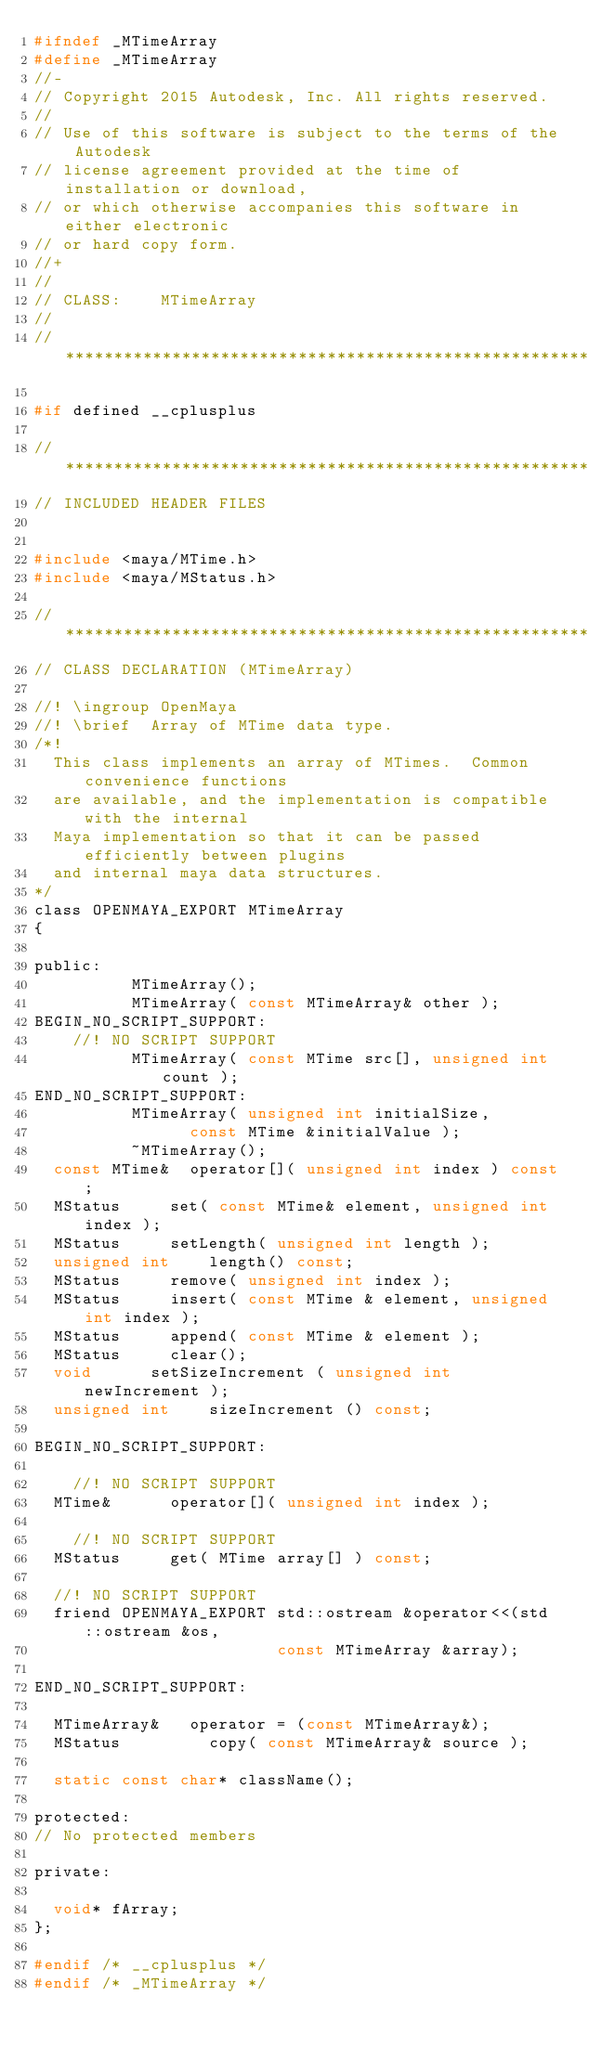Convert code to text. <code><loc_0><loc_0><loc_500><loc_500><_C_>#ifndef _MTimeArray
#define _MTimeArray
//-
// Copyright 2015 Autodesk, Inc. All rights reserved.
// 
// Use of this software is subject to the terms of the Autodesk
// license agreement provided at the time of installation or download,
// or which otherwise accompanies this software in either electronic
// or hard copy form.
//+
//
// CLASS:    MTimeArray
//
// ****************************************************************************

#if defined __cplusplus

// ****************************************************************************
// INCLUDED HEADER FILES


#include <maya/MTime.h>
#include <maya/MStatus.h>

// ****************************************************************************
// CLASS DECLARATION (MTimeArray)

//! \ingroup OpenMaya
//! \brief  Array of MTime data type. 
/*!
	This class implements an array of MTimes.  Common convenience functions
	are available, and the implementation is compatible with the internal
	Maya implementation so that it can be passed efficiently between plugins
	and internal maya data structures.
*/
class OPENMAYA_EXPORT MTimeArray
{

public:
					MTimeArray();
					MTimeArray( const MTimeArray& other );
BEGIN_NO_SCRIPT_SUPPORT:
    //! NO SCRIPT SUPPORT
					MTimeArray( const MTime src[], unsigned int count );
END_NO_SCRIPT_SUPPORT:
					MTimeArray( unsigned int initialSize,
								const MTime &initialValue );
					~MTimeArray();
 	const MTime&	operator[]( unsigned int index ) const;
 	MStatus			set( const MTime& element, unsigned int index );
	MStatus			setLength( unsigned int length );
 	unsigned int		length() const;
 	MStatus			remove( unsigned int index );
 	MStatus			insert( const MTime & element, unsigned int index );
 	MStatus			append( const MTime & element );
 	MStatus			clear();
	void			setSizeIncrement ( unsigned int newIncrement );
	unsigned int		sizeIncrement () const;

BEGIN_NO_SCRIPT_SUPPORT:

    //! NO SCRIPT SUPPORT
 	MTime&			operator[]( unsigned int index );

    //! NO SCRIPT SUPPORT
	MStatus			get( MTime array[] ) const;

	//! NO SCRIPT SUPPORT
	friend OPENMAYA_EXPORT std::ostream &operator<<(std::ostream &os,
											   const MTimeArray &array);

END_NO_SCRIPT_SUPPORT:

	MTimeArray&		operator = (const MTimeArray&);
 	MStatus         copy( const MTimeArray& source );

	static const char* className();

protected:
// No protected members

private:

 	void* fArray;
};

#endif /* __cplusplus */
#endif /* _MTimeArray */
</code> 